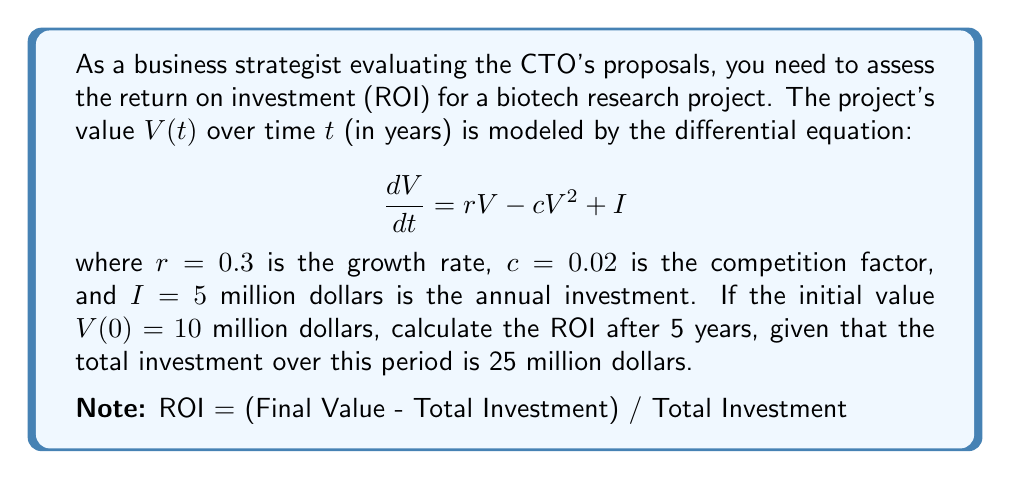Provide a solution to this math problem. To solve this problem, we need to follow these steps:

1) First, we need to solve the differential equation to find $V(5)$. The equation is a Bernoulli differential equation:

   $$\frac{dV}{dt} = rV - cV^2 + I$$

2) The solution to this equation is:

   $$V(t) = \frac{r}{c} + \sqrt{\left(\frac{I}{c}\right)} \tanh\left(\sqrt{rc}\left(t + \frac{1}{2rc}\ln\left(\frac{rV(0)-cV(0)^2+I}{rV(0)-cV(0)^2-I}\right)\right)\right)$$

3) Plugging in our values:
   $r = 0.3$, $c = 0.02$, $I = 5$, $V(0) = 10$, $t = 5$

4) After calculation (which can be done using a computer algebra system), we get:

   $V(5) \approx 25.8439$ million dollars

5) Now we can calculate the ROI:
   ROI = (Final Value - Total Investment) / Total Investment
       = (V(5) - 25) / 25
       = (25.8439 - 25) / 25
       ≈ 0.033756

6) Convert to percentage:
   ROI ≈ 3.3756%
Answer: 3.38% 